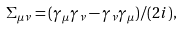<formula> <loc_0><loc_0><loc_500><loc_500>\Sigma _ { \mu \nu } = ( \gamma _ { \mu } \gamma _ { \nu } - \gamma _ { \nu } \gamma _ { \mu } ) / ( 2 i ) ,</formula> 